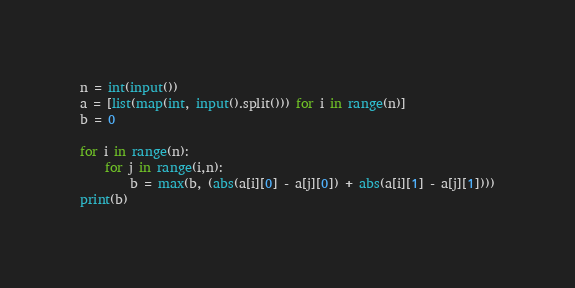<code> <loc_0><loc_0><loc_500><loc_500><_Python_>n = int(input())
a = [list(map(int, input().split())) for i in range(n)]
b = 0

for i in range(n):
    for j in range(i,n):
        b = max(b, (abs(a[i][0] - a[j][0]) + abs(a[i][1] - a[j][1])))
print(b)
</code> 